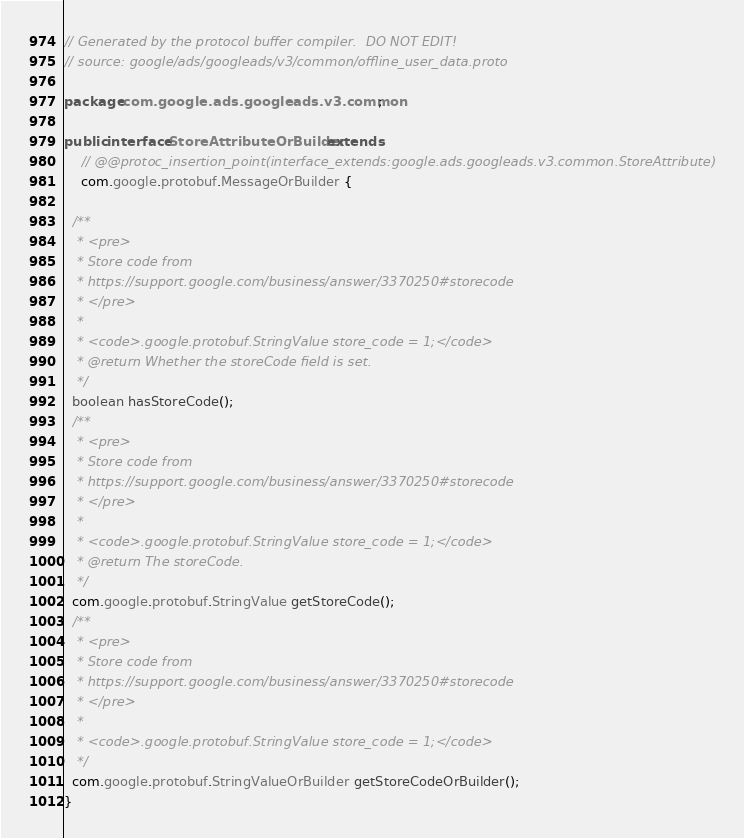Convert code to text. <code><loc_0><loc_0><loc_500><loc_500><_Java_>// Generated by the protocol buffer compiler.  DO NOT EDIT!
// source: google/ads/googleads/v3/common/offline_user_data.proto

package com.google.ads.googleads.v3.common;

public interface StoreAttributeOrBuilder extends
    // @@protoc_insertion_point(interface_extends:google.ads.googleads.v3.common.StoreAttribute)
    com.google.protobuf.MessageOrBuilder {

  /**
   * <pre>
   * Store code from
   * https://support.google.com/business/answer/3370250#storecode
   * </pre>
   *
   * <code>.google.protobuf.StringValue store_code = 1;</code>
   * @return Whether the storeCode field is set.
   */
  boolean hasStoreCode();
  /**
   * <pre>
   * Store code from
   * https://support.google.com/business/answer/3370250#storecode
   * </pre>
   *
   * <code>.google.protobuf.StringValue store_code = 1;</code>
   * @return The storeCode.
   */
  com.google.protobuf.StringValue getStoreCode();
  /**
   * <pre>
   * Store code from
   * https://support.google.com/business/answer/3370250#storecode
   * </pre>
   *
   * <code>.google.protobuf.StringValue store_code = 1;</code>
   */
  com.google.protobuf.StringValueOrBuilder getStoreCodeOrBuilder();
}
</code> 